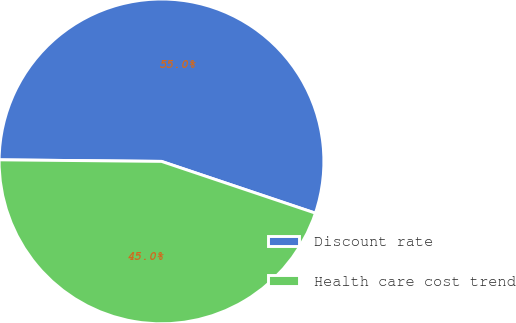<chart> <loc_0><loc_0><loc_500><loc_500><pie_chart><fcel>Discount rate<fcel>Health care cost trend<nl><fcel>55.01%<fcel>44.99%<nl></chart> 